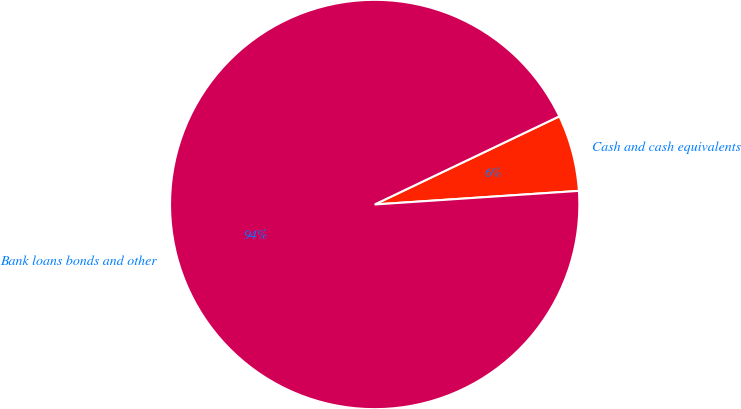Convert chart to OTSL. <chart><loc_0><loc_0><loc_500><loc_500><pie_chart><fcel>Cash and cash equivalents<fcel>Bank loans bonds and other<nl><fcel>6.03%<fcel>93.97%<nl></chart> 